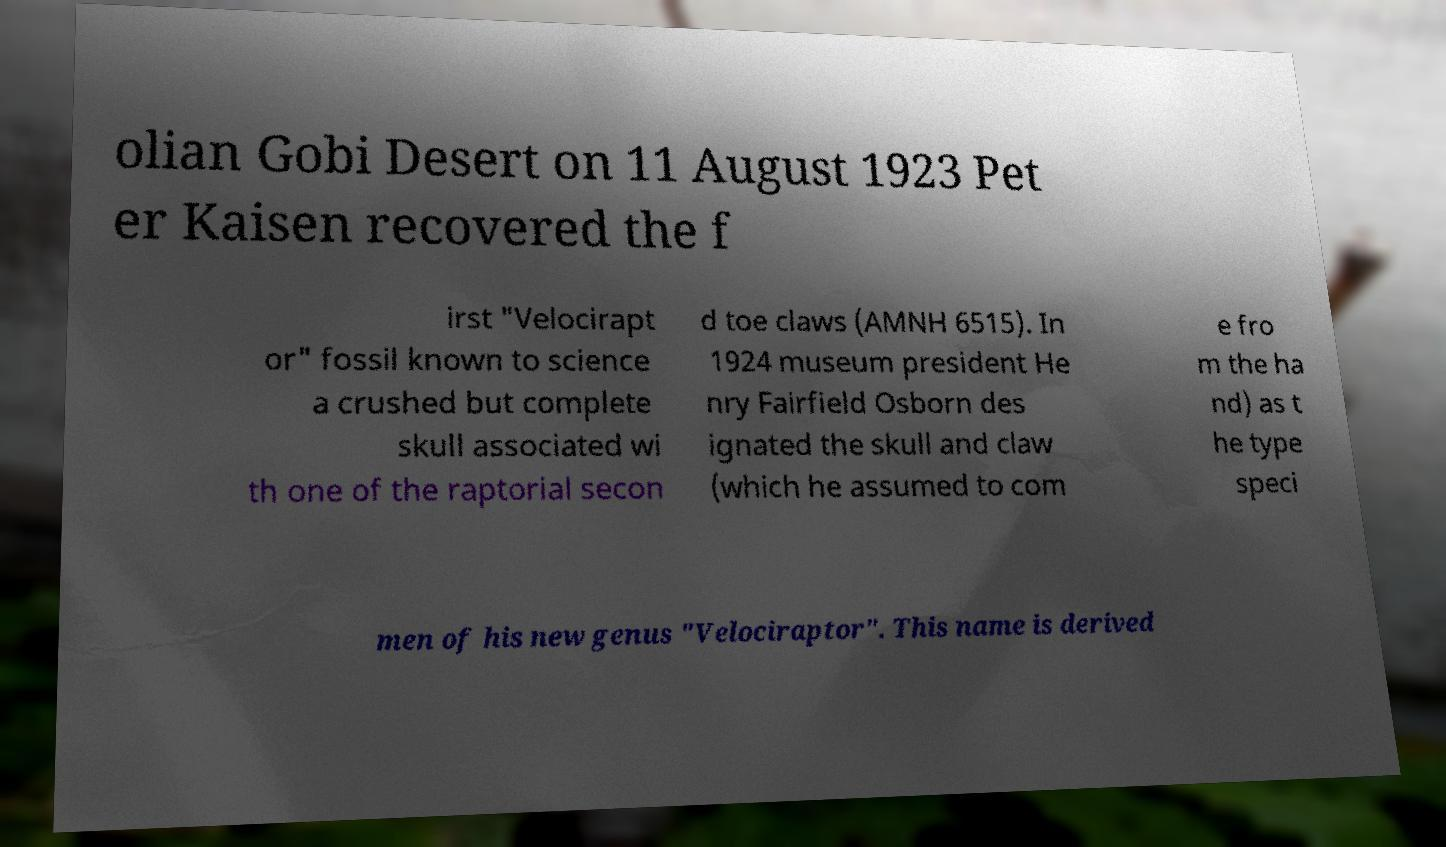What messages or text are displayed in this image? I need them in a readable, typed format. olian Gobi Desert on 11 August 1923 Pet er Kaisen recovered the f irst "Velocirapt or" fossil known to science a crushed but complete skull associated wi th one of the raptorial secon d toe claws (AMNH 6515). In 1924 museum president He nry Fairfield Osborn des ignated the skull and claw (which he assumed to com e fro m the ha nd) as t he type speci men of his new genus "Velociraptor". This name is derived 